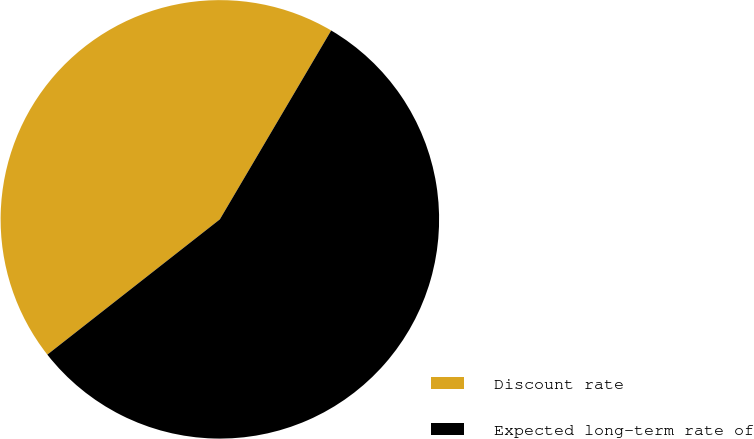Convert chart to OTSL. <chart><loc_0><loc_0><loc_500><loc_500><pie_chart><fcel>Discount rate<fcel>Expected long-term rate of<nl><fcel>44.06%<fcel>55.94%<nl></chart> 